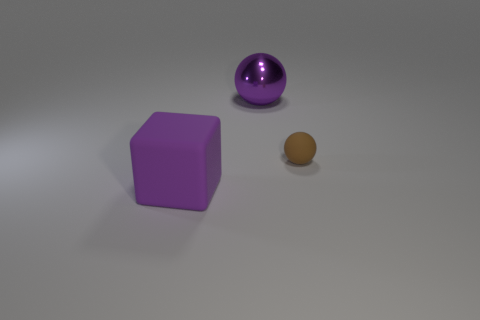Add 2 tiny green rubber things. How many objects exist? 5 Subtract all spheres. How many objects are left? 1 Subtract all big metal blocks. Subtract all large purple matte objects. How many objects are left? 2 Add 2 big purple objects. How many big purple objects are left? 4 Add 3 large purple spheres. How many large purple spheres exist? 4 Subtract 0 blue cylinders. How many objects are left? 3 